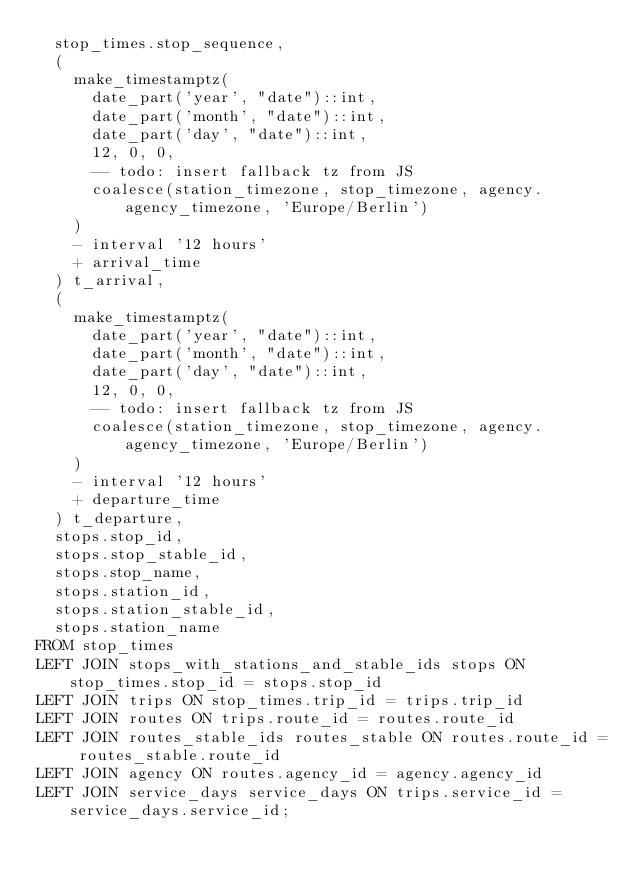<code> <loc_0><loc_0><loc_500><loc_500><_SQL_>	stop_times.stop_sequence,
	(
		make_timestamptz(
			date_part('year', "date")::int,
			date_part('month', "date")::int,
			date_part('day', "date")::int,
			12, 0, 0,
			-- todo: insert fallback tz from JS
			coalesce(station_timezone, stop_timezone, agency.agency_timezone, 'Europe/Berlin')
		)
		- interval '12 hours'
		+ arrival_time
	) t_arrival,
	(
		make_timestamptz(
			date_part('year', "date")::int,
			date_part('month', "date")::int,
			date_part('day', "date")::int,
			12, 0, 0,
			-- todo: insert fallback tz from JS
			coalesce(station_timezone, stop_timezone, agency.agency_timezone, 'Europe/Berlin')
		)
		- interval '12 hours'
		+ departure_time
	) t_departure,
	stops.stop_id,
	stops.stop_stable_id,
	stops.stop_name,
	stops.station_id,
	stops.station_stable_id,
	stops.station_name
FROM stop_times
LEFT JOIN stops_with_stations_and_stable_ids stops ON stop_times.stop_id = stops.stop_id
LEFT JOIN trips ON stop_times.trip_id = trips.trip_id
LEFT JOIN routes ON trips.route_id = routes.route_id
LEFT JOIN routes_stable_ids routes_stable ON routes.route_id = routes_stable.route_id
LEFT JOIN agency ON routes.agency_id = agency.agency_id
LEFT JOIN service_days service_days ON trips.service_id = service_days.service_id;
</code> 